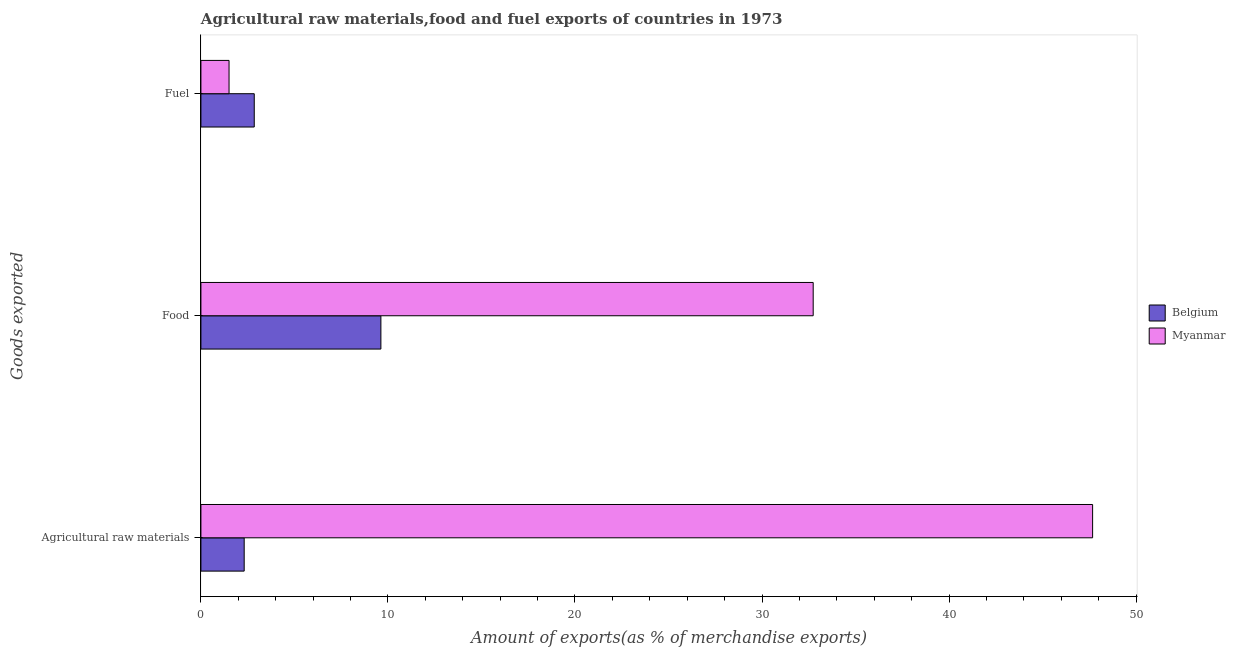How many different coloured bars are there?
Give a very brief answer. 2. Are the number of bars per tick equal to the number of legend labels?
Ensure brevity in your answer.  Yes. Are the number of bars on each tick of the Y-axis equal?
Ensure brevity in your answer.  Yes. What is the label of the 1st group of bars from the top?
Provide a succinct answer. Fuel. What is the percentage of food exports in Belgium?
Offer a terse response. 9.62. Across all countries, what is the maximum percentage of raw materials exports?
Your answer should be compact. 47.68. Across all countries, what is the minimum percentage of raw materials exports?
Make the answer very short. 2.31. In which country was the percentage of food exports maximum?
Your answer should be compact. Myanmar. In which country was the percentage of raw materials exports minimum?
Your response must be concise. Belgium. What is the total percentage of food exports in the graph?
Your response must be concise. 42.36. What is the difference between the percentage of food exports in Belgium and that in Myanmar?
Keep it short and to the point. -23.11. What is the difference between the percentage of food exports in Belgium and the percentage of fuel exports in Myanmar?
Give a very brief answer. 8.12. What is the average percentage of fuel exports per country?
Your answer should be compact. 2.18. What is the difference between the percentage of food exports and percentage of fuel exports in Myanmar?
Your answer should be compact. 31.23. In how many countries, is the percentage of food exports greater than 28 %?
Your answer should be very brief. 1. What is the ratio of the percentage of raw materials exports in Belgium to that in Myanmar?
Offer a terse response. 0.05. Is the difference between the percentage of food exports in Myanmar and Belgium greater than the difference between the percentage of fuel exports in Myanmar and Belgium?
Your answer should be very brief. Yes. What is the difference between the highest and the second highest percentage of food exports?
Make the answer very short. 23.11. What is the difference between the highest and the lowest percentage of food exports?
Ensure brevity in your answer.  23.11. In how many countries, is the percentage of food exports greater than the average percentage of food exports taken over all countries?
Provide a succinct answer. 1. Is the sum of the percentage of raw materials exports in Belgium and Myanmar greater than the maximum percentage of food exports across all countries?
Make the answer very short. Yes. Are all the bars in the graph horizontal?
Keep it short and to the point. Yes. What is the difference between two consecutive major ticks on the X-axis?
Keep it short and to the point. 10. Does the graph contain any zero values?
Your answer should be compact. No. Where does the legend appear in the graph?
Provide a short and direct response. Center right. How many legend labels are there?
Your answer should be compact. 2. How are the legend labels stacked?
Make the answer very short. Vertical. What is the title of the graph?
Offer a terse response. Agricultural raw materials,food and fuel exports of countries in 1973. Does "Andorra" appear as one of the legend labels in the graph?
Your answer should be compact. No. What is the label or title of the X-axis?
Ensure brevity in your answer.  Amount of exports(as % of merchandise exports). What is the label or title of the Y-axis?
Your answer should be very brief. Goods exported. What is the Amount of exports(as % of merchandise exports) of Belgium in Agricultural raw materials?
Make the answer very short. 2.31. What is the Amount of exports(as % of merchandise exports) in Myanmar in Agricultural raw materials?
Your answer should be compact. 47.68. What is the Amount of exports(as % of merchandise exports) in Belgium in Food?
Provide a succinct answer. 9.62. What is the Amount of exports(as % of merchandise exports) in Myanmar in Food?
Your response must be concise. 32.74. What is the Amount of exports(as % of merchandise exports) of Belgium in Fuel?
Your answer should be compact. 2.85. What is the Amount of exports(as % of merchandise exports) of Myanmar in Fuel?
Your answer should be very brief. 1.5. Across all Goods exported, what is the maximum Amount of exports(as % of merchandise exports) in Belgium?
Ensure brevity in your answer.  9.62. Across all Goods exported, what is the maximum Amount of exports(as % of merchandise exports) in Myanmar?
Your answer should be compact. 47.68. Across all Goods exported, what is the minimum Amount of exports(as % of merchandise exports) of Belgium?
Offer a terse response. 2.31. Across all Goods exported, what is the minimum Amount of exports(as % of merchandise exports) of Myanmar?
Ensure brevity in your answer.  1.5. What is the total Amount of exports(as % of merchandise exports) of Belgium in the graph?
Make the answer very short. 14.79. What is the total Amount of exports(as % of merchandise exports) of Myanmar in the graph?
Your answer should be very brief. 81.92. What is the difference between the Amount of exports(as % of merchandise exports) in Belgium in Agricultural raw materials and that in Food?
Give a very brief answer. -7.31. What is the difference between the Amount of exports(as % of merchandise exports) in Myanmar in Agricultural raw materials and that in Food?
Offer a terse response. 14.94. What is the difference between the Amount of exports(as % of merchandise exports) of Belgium in Agricultural raw materials and that in Fuel?
Provide a succinct answer. -0.54. What is the difference between the Amount of exports(as % of merchandise exports) in Myanmar in Agricultural raw materials and that in Fuel?
Provide a succinct answer. 46.17. What is the difference between the Amount of exports(as % of merchandise exports) of Belgium in Food and that in Fuel?
Offer a terse response. 6.77. What is the difference between the Amount of exports(as % of merchandise exports) of Myanmar in Food and that in Fuel?
Offer a terse response. 31.23. What is the difference between the Amount of exports(as % of merchandise exports) of Belgium in Agricultural raw materials and the Amount of exports(as % of merchandise exports) of Myanmar in Food?
Your response must be concise. -30.42. What is the difference between the Amount of exports(as % of merchandise exports) of Belgium in Agricultural raw materials and the Amount of exports(as % of merchandise exports) of Myanmar in Fuel?
Ensure brevity in your answer.  0.81. What is the difference between the Amount of exports(as % of merchandise exports) of Belgium in Food and the Amount of exports(as % of merchandise exports) of Myanmar in Fuel?
Ensure brevity in your answer.  8.12. What is the average Amount of exports(as % of merchandise exports) in Belgium per Goods exported?
Keep it short and to the point. 4.93. What is the average Amount of exports(as % of merchandise exports) of Myanmar per Goods exported?
Ensure brevity in your answer.  27.31. What is the difference between the Amount of exports(as % of merchandise exports) in Belgium and Amount of exports(as % of merchandise exports) in Myanmar in Agricultural raw materials?
Give a very brief answer. -45.36. What is the difference between the Amount of exports(as % of merchandise exports) in Belgium and Amount of exports(as % of merchandise exports) in Myanmar in Food?
Provide a short and direct response. -23.11. What is the difference between the Amount of exports(as % of merchandise exports) in Belgium and Amount of exports(as % of merchandise exports) in Myanmar in Fuel?
Keep it short and to the point. 1.35. What is the ratio of the Amount of exports(as % of merchandise exports) of Belgium in Agricultural raw materials to that in Food?
Your response must be concise. 0.24. What is the ratio of the Amount of exports(as % of merchandise exports) of Myanmar in Agricultural raw materials to that in Food?
Make the answer very short. 1.46. What is the ratio of the Amount of exports(as % of merchandise exports) of Belgium in Agricultural raw materials to that in Fuel?
Offer a very short reply. 0.81. What is the ratio of the Amount of exports(as % of merchandise exports) of Myanmar in Agricultural raw materials to that in Fuel?
Your answer should be compact. 31.7. What is the ratio of the Amount of exports(as % of merchandise exports) in Belgium in Food to that in Fuel?
Offer a very short reply. 3.37. What is the ratio of the Amount of exports(as % of merchandise exports) in Myanmar in Food to that in Fuel?
Your answer should be very brief. 21.77. What is the difference between the highest and the second highest Amount of exports(as % of merchandise exports) in Belgium?
Offer a very short reply. 6.77. What is the difference between the highest and the second highest Amount of exports(as % of merchandise exports) of Myanmar?
Offer a terse response. 14.94. What is the difference between the highest and the lowest Amount of exports(as % of merchandise exports) of Belgium?
Your answer should be very brief. 7.31. What is the difference between the highest and the lowest Amount of exports(as % of merchandise exports) in Myanmar?
Your response must be concise. 46.17. 